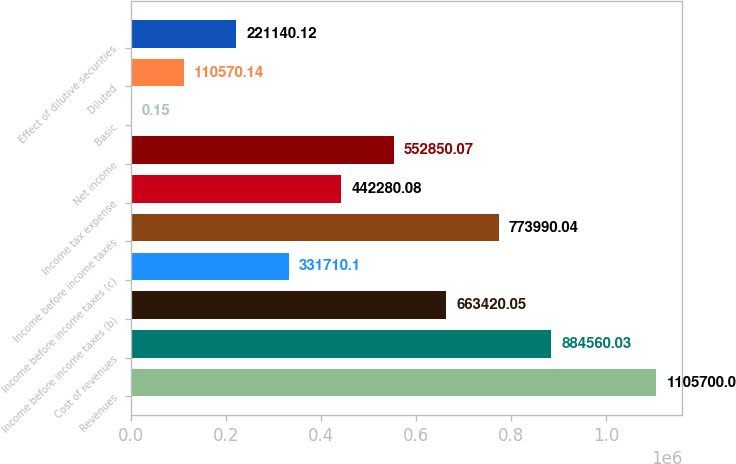Convert chart to OTSL. <chart><loc_0><loc_0><loc_500><loc_500><bar_chart><fcel>Revenues<fcel>Cost of revenues<fcel>Income before income taxes (b)<fcel>Income before income taxes (c)<fcel>Income before income taxes<fcel>Income tax expense<fcel>Net income<fcel>Basic<fcel>Diluted<fcel>Effect of dilutive securities<nl><fcel>1.1057e+06<fcel>884560<fcel>663420<fcel>331710<fcel>773990<fcel>442280<fcel>552850<fcel>0.15<fcel>110570<fcel>221140<nl></chart> 